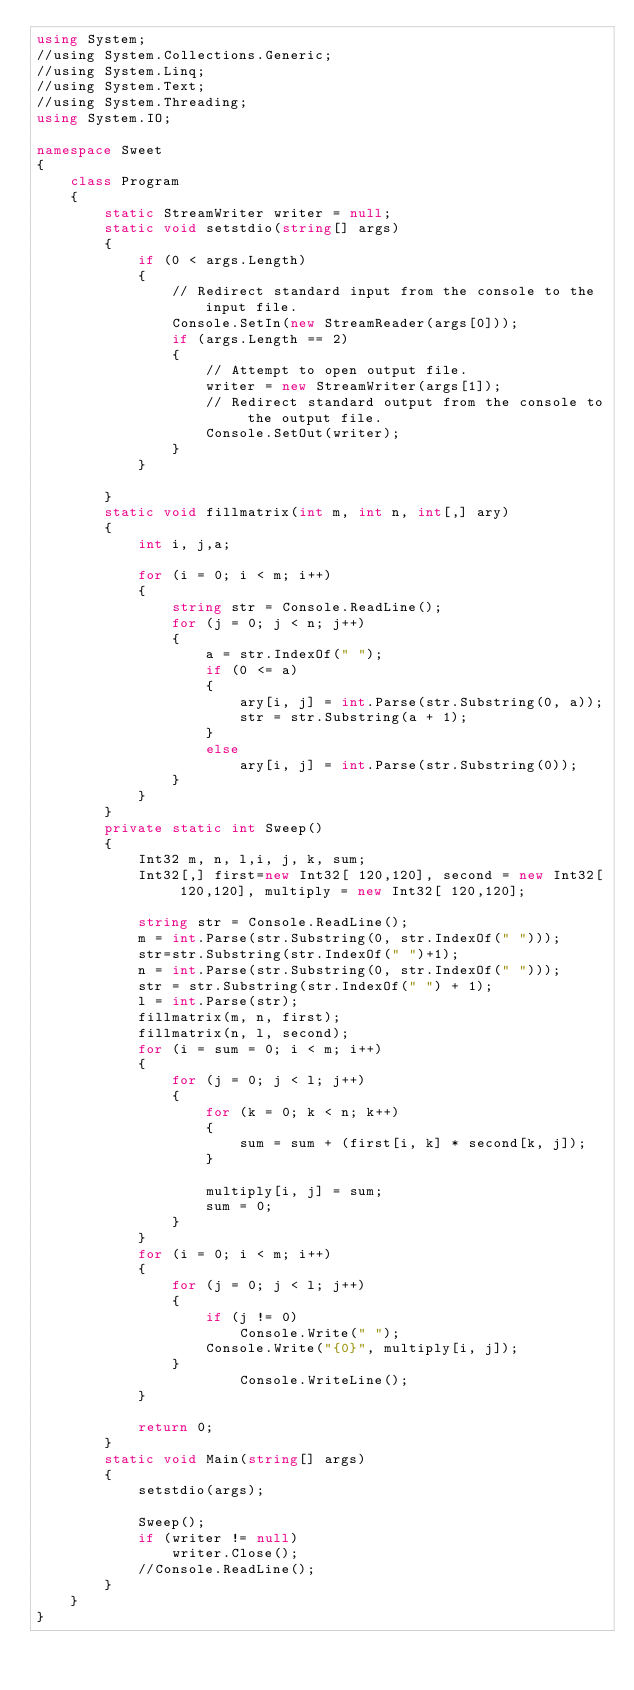<code> <loc_0><loc_0><loc_500><loc_500><_C#_>using System;
//using System.Collections.Generic;
//using System.Linq;
//using System.Text;
//using System.Threading;
using System.IO;

namespace Sweet
{
    class Program
    {
        static StreamWriter writer = null;
        static void setstdio(string[] args)
        {
            if (0 < args.Length)
            {
                // Redirect standard input from the console to the input file.
                Console.SetIn(new StreamReader(args[0]));
                if (args.Length == 2)
                {
                    // Attempt to open output file.
                    writer = new StreamWriter(args[1]);
                    // Redirect standard output from the console to the output file.
                    Console.SetOut(writer);
                }
            }

        }
        static void fillmatrix(int m, int n, int[,] ary)
        {
            int i, j,a;

            for (i = 0; i < m; i++)
            {
                string str = Console.ReadLine();
                for (j = 0; j < n; j++)
                {
                    a = str.IndexOf(" ");
                    if (0 <= a)
                    {
                        ary[i, j] = int.Parse(str.Substring(0, a));
                        str = str.Substring(a + 1);
                    }
                    else
                        ary[i, j] = int.Parse(str.Substring(0));
                }
            }
        }
        private static int Sweep()
        {
            Int32 m, n, l,i, j, k, sum;
            Int32[,] first=new Int32[ 120,120], second = new Int32[ 120,120], multiply = new Int32[ 120,120];

            string str = Console.ReadLine();
            m = int.Parse(str.Substring(0, str.IndexOf(" ")));
            str=str.Substring(str.IndexOf(" ")+1);
            n = int.Parse(str.Substring(0, str.IndexOf(" ")));
            str = str.Substring(str.IndexOf(" ") + 1);
            l = int.Parse(str);
            fillmatrix(m, n, first);
            fillmatrix(n, l, second);
            for (i = sum = 0; i < m; i++)
            {
                for (j = 0; j < l; j++)
                {
                    for (k = 0; k < n; k++)
                    {
                        sum = sum + (first[i, k] * second[k, j]);
                    }

                    multiply[i, j] = sum;
                    sum = 0;
                }
            }
            for (i = 0; i < m; i++)
            {
                for (j = 0; j < l; j++)
                {
                    if (j != 0)
                        Console.Write(" ");
                    Console.Write("{0}", multiply[i, j]);
                }
                        Console.WriteLine();
            }

            return 0;
        }
        static void Main(string[] args)
        {
            setstdio(args);

            Sweep();
            if (writer != null)
                writer.Close();
            //Console.ReadLine();
        }
    }
}</code> 